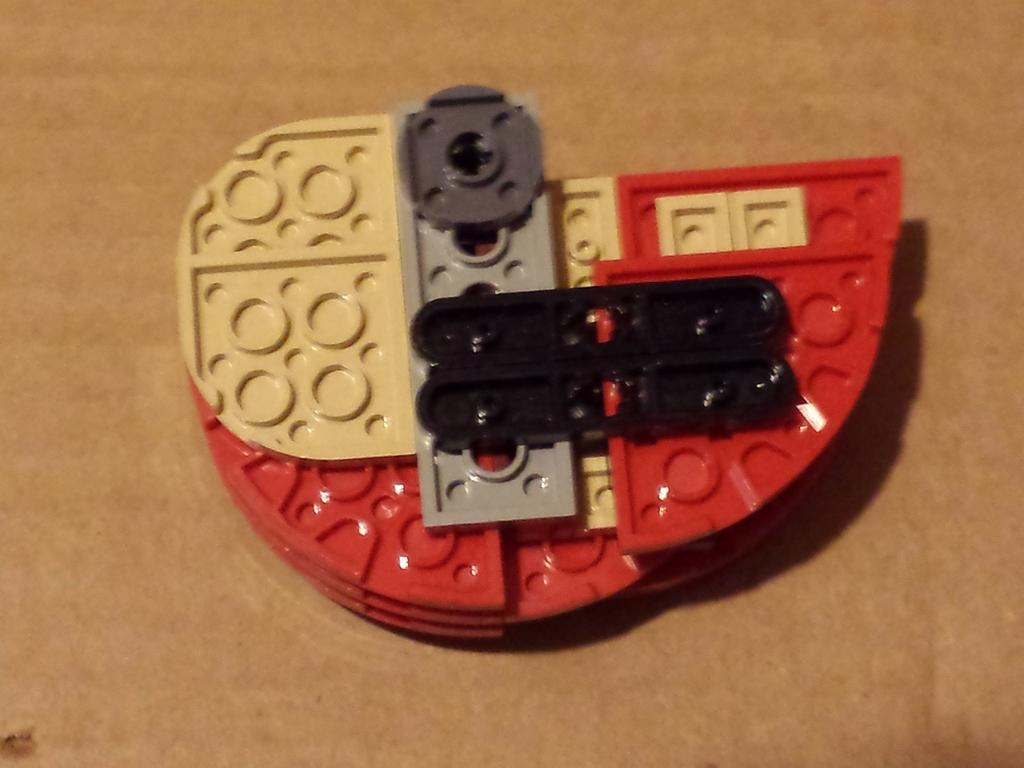What is the surface visible in the image? There is a floor in the image. What object can be seen on the floor? There is a toy present on the floor. What type of protest is taking place in the image? There is no protest present in the image; it only features a floor and a toy. How many babies are visible in the image? There are no babies present in the image. 